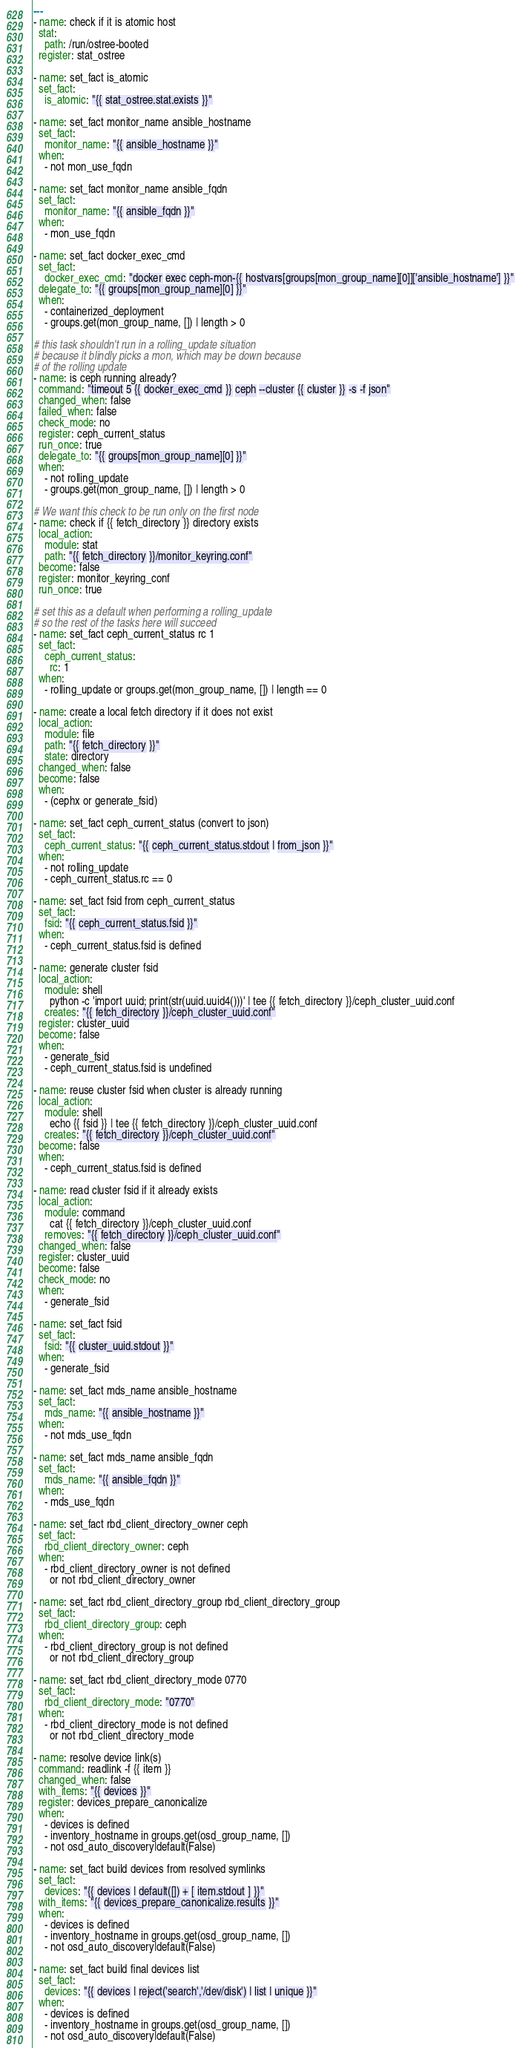Convert code to text. <code><loc_0><loc_0><loc_500><loc_500><_YAML_>---
- name: check if it is atomic host
  stat:
    path: /run/ostree-booted
  register: stat_ostree

- name: set_fact is_atomic
  set_fact:
    is_atomic: "{{ stat_ostree.stat.exists }}"

- name: set_fact monitor_name ansible_hostname
  set_fact:
    monitor_name: "{{ ansible_hostname }}"
  when:
    - not mon_use_fqdn

- name: set_fact monitor_name ansible_fqdn
  set_fact:
    monitor_name: "{{ ansible_fqdn }}"
  when:
    - mon_use_fqdn

- name: set_fact docker_exec_cmd
  set_fact:
    docker_exec_cmd: "docker exec ceph-mon-{{ hostvars[groups[mon_group_name][0]]['ansible_hostname'] }}"
  delegate_to: "{{ groups[mon_group_name][0] }}"
  when:
    - containerized_deployment
    - groups.get(mon_group_name, []) | length > 0

# this task shouldn't run in a rolling_update situation
# because it blindly picks a mon, which may be down because
# of the rolling update
- name: is ceph running already?
  command: "timeout 5 {{ docker_exec_cmd }} ceph --cluster {{ cluster }} -s -f json"
  changed_when: false
  failed_when: false
  check_mode: no
  register: ceph_current_status
  run_once: true
  delegate_to: "{{ groups[mon_group_name][0] }}"
  when:
    - not rolling_update
    - groups.get(mon_group_name, []) | length > 0

# We want this check to be run only on the first node
- name: check if {{ fetch_directory }} directory exists
  local_action:
    module: stat
    path: "{{ fetch_directory }}/monitor_keyring.conf"
  become: false
  register: monitor_keyring_conf
  run_once: true

# set this as a default when performing a rolling_update
# so the rest of the tasks here will succeed
- name: set_fact ceph_current_status rc 1
  set_fact:
    ceph_current_status:
      rc: 1
  when:
    - rolling_update or groups.get(mon_group_name, []) | length == 0

- name: create a local fetch directory if it does not exist
  local_action:
    module: file
    path: "{{ fetch_directory }}"
    state: directory
  changed_when: false
  become: false
  when:
    - (cephx or generate_fsid)

- name: set_fact ceph_current_status (convert to json)
  set_fact:
    ceph_current_status: "{{ ceph_current_status.stdout | from_json }}"
  when:
    - not rolling_update
    - ceph_current_status.rc == 0

- name: set_fact fsid from ceph_current_status
  set_fact:
    fsid: "{{ ceph_current_status.fsid }}"
  when:
    - ceph_current_status.fsid is defined

- name: generate cluster fsid
  local_action:
    module: shell
      python -c 'import uuid; print(str(uuid.uuid4()))' | tee {{ fetch_directory }}/ceph_cluster_uuid.conf
    creates: "{{ fetch_directory }}/ceph_cluster_uuid.conf"
  register: cluster_uuid
  become: false
  when:
    - generate_fsid
    - ceph_current_status.fsid is undefined

- name: reuse cluster fsid when cluster is already running
  local_action:
    module: shell
      echo {{ fsid }} | tee {{ fetch_directory }}/ceph_cluster_uuid.conf
    creates: "{{ fetch_directory }}/ceph_cluster_uuid.conf"
  become: false
  when:
    - ceph_current_status.fsid is defined

- name: read cluster fsid if it already exists
  local_action:
    module: command
      cat {{ fetch_directory }}/ceph_cluster_uuid.conf
    removes: "{{ fetch_directory }}/ceph_cluster_uuid.conf"
  changed_when: false
  register: cluster_uuid
  become: false
  check_mode: no
  when:
    - generate_fsid

- name: set_fact fsid
  set_fact:
    fsid: "{{ cluster_uuid.stdout }}"
  when:
    - generate_fsid

- name: set_fact mds_name ansible_hostname
  set_fact:
    mds_name: "{{ ansible_hostname }}"
  when:
    - not mds_use_fqdn

- name: set_fact mds_name ansible_fqdn
  set_fact:
    mds_name: "{{ ansible_fqdn }}"
  when:
    - mds_use_fqdn

- name: set_fact rbd_client_directory_owner ceph
  set_fact:
    rbd_client_directory_owner: ceph
  when:
    - rbd_client_directory_owner is not defined
      or not rbd_client_directory_owner

- name: set_fact rbd_client_directory_group rbd_client_directory_group
  set_fact:
    rbd_client_directory_group: ceph
  when:
    - rbd_client_directory_group is not defined
      or not rbd_client_directory_group

- name: set_fact rbd_client_directory_mode 0770
  set_fact:
    rbd_client_directory_mode: "0770"
  when:
    - rbd_client_directory_mode is not defined
      or not rbd_client_directory_mode

- name: resolve device link(s)
  command: readlink -f {{ item }}
  changed_when: false
  with_items: "{{ devices }}"
  register: devices_prepare_canonicalize
  when:
    - devices is defined
    - inventory_hostname in groups.get(osd_group_name, [])
    - not osd_auto_discovery|default(False)

- name: set_fact build devices from resolved symlinks
  set_fact:
    devices: "{{ devices | default([]) + [ item.stdout ] }}"
  with_items: "{{ devices_prepare_canonicalize.results }}"
  when:
    - devices is defined
    - inventory_hostname in groups.get(osd_group_name, [])
    - not osd_auto_discovery|default(False)

- name: set_fact build final devices list
  set_fact:
    devices: "{{ devices | reject('search','/dev/disk') | list | unique }}"
  when:
    - devices is defined
    - inventory_hostname in groups.get(osd_group_name, [])
    - not osd_auto_discovery|default(False)
</code> 